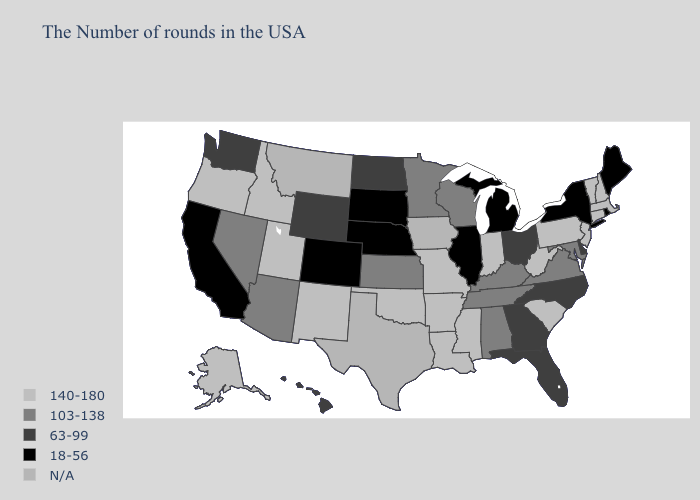What is the value of Wisconsin?
Concise answer only. 103-138. Name the states that have a value in the range 140-180?
Give a very brief answer. Massachusetts, New Hampshire, Vermont, Connecticut, New Jersey, Pennsylvania, South Carolina, West Virginia, Indiana, Mississippi, Louisiana, Missouri, Arkansas, Oklahoma, New Mexico, Utah, Idaho, Oregon, Alaska. Name the states that have a value in the range 140-180?
Quick response, please. Massachusetts, New Hampshire, Vermont, Connecticut, New Jersey, Pennsylvania, South Carolina, West Virginia, Indiana, Mississippi, Louisiana, Missouri, Arkansas, Oklahoma, New Mexico, Utah, Idaho, Oregon, Alaska. What is the value of New York?
Concise answer only. 18-56. What is the value of Kansas?
Keep it brief. 103-138. Among the states that border Virginia , which have the lowest value?
Quick response, please. North Carolina. Name the states that have a value in the range 140-180?
Keep it brief. Massachusetts, New Hampshire, Vermont, Connecticut, New Jersey, Pennsylvania, South Carolina, West Virginia, Indiana, Mississippi, Louisiana, Missouri, Arkansas, Oklahoma, New Mexico, Utah, Idaho, Oregon, Alaska. Among the states that border Arkansas , does Tennessee have the highest value?
Concise answer only. No. Name the states that have a value in the range 103-138?
Concise answer only. Maryland, Virginia, Kentucky, Alabama, Tennessee, Wisconsin, Minnesota, Kansas, Arizona, Nevada. Name the states that have a value in the range 103-138?
Short answer required. Maryland, Virginia, Kentucky, Alabama, Tennessee, Wisconsin, Minnesota, Kansas, Arizona, Nevada. What is the value of Virginia?
Concise answer only. 103-138. Name the states that have a value in the range 140-180?
Answer briefly. Massachusetts, New Hampshire, Vermont, Connecticut, New Jersey, Pennsylvania, South Carolina, West Virginia, Indiana, Mississippi, Louisiana, Missouri, Arkansas, Oklahoma, New Mexico, Utah, Idaho, Oregon, Alaska. Which states have the highest value in the USA?
Give a very brief answer. Massachusetts, New Hampshire, Vermont, Connecticut, New Jersey, Pennsylvania, South Carolina, West Virginia, Indiana, Mississippi, Louisiana, Missouri, Arkansas, Oklahoma, New Mexico, Utah, Idaho, Oregon, Alaska. Name the states that have a value in the range 140-180?
Give a very brief answer. Massachusetts, New Hampshire, Vermont, Connecticut, New Jersey, Pennsylvania, South Carolina, West Virginia, Indiana, Mississippi, Louisiana, Missouri, Arkansas, Oklahoma, New Mexico, Utah, Idaho, Oregon, Alaska. 